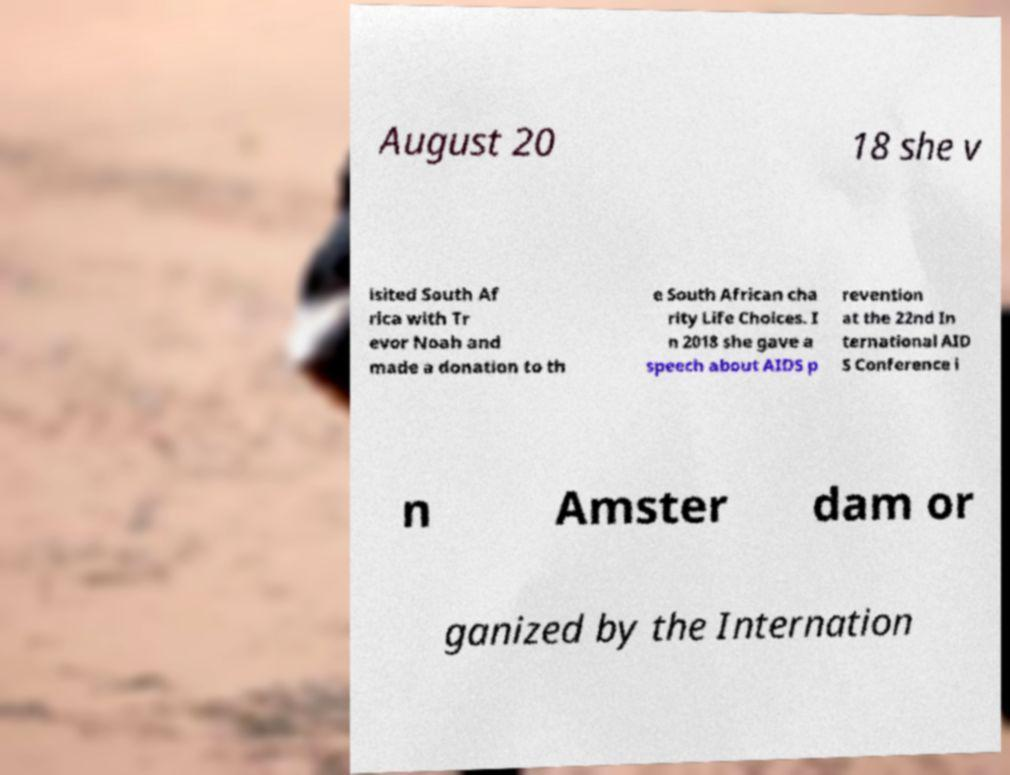Can you accurately transcribe the text from the provided image for me? August 20 18 she v isited South Af rica with Tr evor Noah and made a donation to th e South African cha rity Life Choices. I n 2018 she gave a speech about AIDS p revention at the 22nd In ternational AID S Conference i n Amster dam or ganized by the Internation 